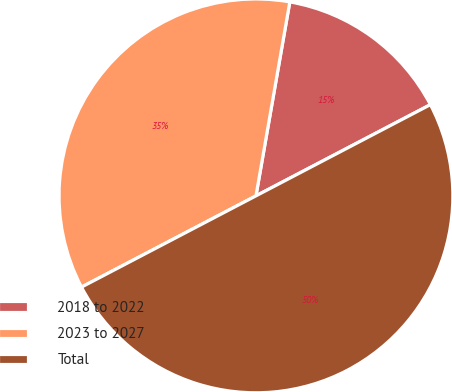Convert chart to OTSL. <chart><loc_0><loc_0><loc_500><loc_500><pie_chart><fcel>2018 to 2022<fcel>2023 to 2027<fcel>Total<nl><fcel>14.58%<fcel>35.42%<fcel>50.0%<nl></chart> 